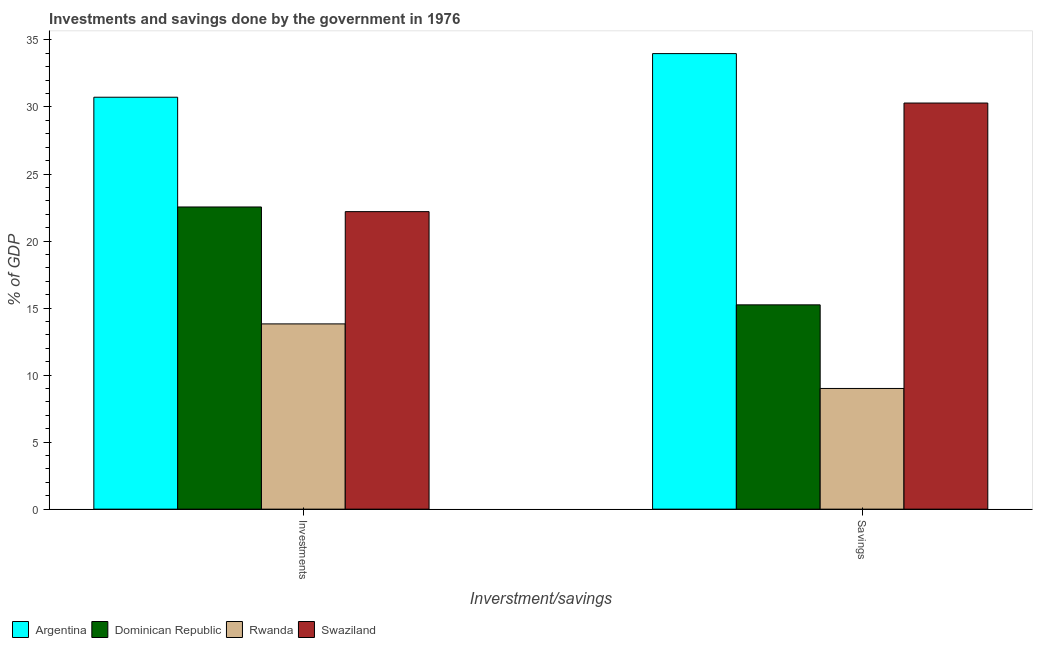How many different coloured bars are there?
Make the answer very short. 4. How many groups of bars are there?
Provide a succinct answer. 2. Are the number of bars on each tick of the X-axis equal?
Provide a succinct answer. Yes. What is the label of the 1st group of bars from the left?
Your response must be concise. Investments. What is the investments of government in Swaziland?
Offer a terse response. 22.19. Across all countries, what is the maximum investments of government?
Ensure brevity in your answer.  30.73. Across all countries, what is the minimum savings of government?
Provide a short and direct response. 9. In which country was the savings of government minimum?
Your answer should be compact. Rwanda. What is the total savings of government in the graph?
Give a very brief answer. 88.52. What is the difference between the investments of government in Argentina and that in Rwanda?
Provide a succinct answer. 16.91. What is the difference between the investments of government in Rwanda and the savings of government in Argentina?
Keep it short and to the point. -20.16. What is the average investments of government per country?
Keep it short and to the point. 22.32. What is the difference between the investments of government and savings of government in Rwanda?
Provide a short and direct response. 4.82. In how many countries, is the savings of government greater than 22 %?
Provide a succinct answer. 2. What is the ratio of the investments of government in Argentina to that in Swaziland?
Give a very brief answer. 1.38. Is the investments of government in Swaziland less than that in Dominican Republic?
Ensure brevity in your answer.  Yes. What does the 4th bar from the left in Investments represents?
Offer a terse response. Swaziland. What does the 3rd bar from the right in Investments represents?
Make the answer very short. Dominican Republic. Are all the bars in the graph horizontal?
Offer a very short reply. No. How many countries are there in the graph?
Provide a succinct answer. 4. Does the graph contain grids?
Provide a succinct answer. No. Where does the legend appear in the graph?
Your response must be concise. Bottom left. How many legend labels are there?
Provide a succinct answer. 4. How are the legend labels stacked?
Your answer should be compact. Horizontal. What is the title of the graph?
Your response must be concise. Investments and savings done by the government in 1976. What is the label or title of the X-axis?
Offer a very short reply. Inverstment/savings. What is the label or title of the Y-axis?
Provide a short and direct response. % of GDP. What is the % of GDP of Argentina in Investments?
Keep it short and to the point. 30.73. What is the % of GDP of Dominican Republic in Investments?
Your response must be concise. 22.54. What is the % of GDP of Rwanda in Investments?
Provide a succinct answer. 13.82. What is the % of GDP of Swaziland in Investments?
Give a very brief answer. 22.19. What is the % of GDP in Argentina in Savings?
Provide a short and direct response. 33.98. What is the % of GDP of Dominican Republic in Savings?
Make the answer very short. 15.24. What is the % of GDP of Rwanda in Savings?
Keep it short and to the point. 9. What is the % of GDP of Swaziland in Savings?
Your response must be concise. 30.3. Across all Inverstment/savings, what is the maximum % of GDP of Argentina?
Your answer should be compact. 33.98. Across all Inverstment/savings, what is the maximum % of GDP in Dominican Republic?
Provide a succinct answer. 22.54. Across all Inverstment/savings, what is the maximum % of GDP in Rwanda?
Offer a very short reply. 13.82. Across all Inverstment/savings, what is the maximum % of GDP of Swaziland?
Your answer should be compact. 30.3. Across all Inverstment/savings, what is the minimum % of GDP in Argentina?
Your response must be concise. 30.73. Across all Inverstment/savings, what is the minimum % of GDP in Dominican Republic?
Provide a succinct answer. 15.24. Across all Inverstment/savings, what is the minimum % of GDP of Rwanda?
Keep it short and to the point. 9. Across all Inverstment/savings, what is the minimum % of GDP in Swaziland?
Your answer should be very brief. 22.19. What is the total % of GDP of Argentina in the graph?
Ensure brevity in your answer.  64.71. What is the total % of GDP of Dominican Republic in the graph?
Keep it short and to the point. 37.78. What is the total % of GDP of Rwanda in the graph?
Keep it short and to the point. 22.82. What is the total % of GDP in Swaziland in the graph?
Provide a short and direct response. 52.49. What is the difference between the % of GDP in Argentina in Investments and that in Savings?
Ensure brevity in your answer.  -3.25. What is the difference between the % of GDP of Dominican Republic in Investments and that in Savings?
Offer a very short reply. 7.3. What is the difference between the % of GDP in Rwanda in Investments and that in Savings?
Make the answer very short. 4.82. What is the difference between the % of GDP of Swaziland in Investments and that in Savings?
Your response must be concise. -8.1. What is the difference between the % of GDP of Argentina in Investments and the % of GDP of Dominican Republic in Savings?
Keep it short and to the point. 15.49. What is the difference between the % of GDP of Argentina in Investments and the % of GDP of Rwanda in Savings?
Make the answer very short. 21.73. What is the difference between the % of GDP of Argentina in Investments and the % of GDP of Swaziland in Savings?
Keep it short and to the point. 0.43. What is the difference between the % of GDP of Dominican Republic in Investments and the % of GDP of Rwanda in Savings?
Keep it short and to the point. 13.54. What is the difference between the % of GDP of Dominican Republic in Investments and the % of GDP of Swaziland in Savings?
Your answer should be compact. -7.75. What is the difference between the % of GDP in Rwanda in Investments and the % of GDP in Swaziland in Savings?
Provide a succinct answer. -16.48. What is the average % of GDP in Argentina per Inverstment/savings?
Give a very brief answer. 32.36. What is the average % of GDP in Dominican Republic per Inverstment/savings?
Keep it short and to the point. 18.89. What is the average % of GDP of Rwanda per Inverstment/savings?
Give a very brief answer. 11.41. What is the average % of GDP in Swaziland per Inverstment/savings?
Ensure brevity in your answer.  26.24. What is the difference between the % of GDP in Argentina and % of GDP in Dominican Republic in Investments?
Give a very brief answer. 8.19. What is the difference between the % of GDP in Argentina and % of GDP in Rwanda in Investments?
Provide a short and direct response. 16.91. What is the difference between the % of GDP of Argentina and % of GDP of Swaziland in Investments?
Make the answer very short. 8.54. What is the difference between the % of GDP in Dominican Republic and % of GDP in Rwanda in Investments?
Keep it short and to the point. 8.72. What is the difference between the % of GDP of Dominican Republic and % of GDP of Swaziland in Investments?
Offer a terse response. 0.35. What is the difference between the % of GDP of Rwanda and % of GDP of Swaziland in Investments?
Offer a very short reply. -8.37. What is the difference between the % of GDP of Argentina and % of GDP of Dominican Republic in Savings?
Your answer should be very brief. 18.74. What is the difference between the % of GDP in Argentina and % of GDP in Rwanda in Savings?
Your response must be concise. 24.98. What is the difference between the % of GDP in Argentina and % of GDP in Swaziland in Savings?
Offer a very short reply. 3.69. What is the difference between the % of GDP in Dominican Republic and % of GDP in Rwanda in Savings?
Provide a succinct answer. 6.24. What is the difference between the % of GDP in Dominican Republic and % of GDP in Swaziland in Savings?
Your answer should be very brief. -15.06. What is the difference between the % of GDP of Rwanda and % of GDP of Swaziland in Savings?
Offer a very short reply. -21.29. What is the ratio of the % of GDP of Argentina in Investments to that in Savings?
Offer a terse response. 0.9. What is the ratio of the % of GDP in Dominican Republic in Investments to that in Savings?
Give a very brief answer. 1.48. What is the ratio of the % of GDP of Rwanda in Investments to that in Savings?
Provide a succinct answer. 1.53. What is the ratio of the % of GDP of Swaziland in Investments to that in Savings?
Offer a terse response. 0.73. What is the difference between the highest and the second highest % of GDP in Argentina?
Keep it short and to the point. 3.25. What is the difference between the highest and the second highest % of GDP of Dominican Republic?
Keep it short and to the point. 7.3. What is the difference between the highest and the second highest % of GDP in Rwanda?
Provide a succinct answer. 4.82. What is the difference between the highest and the second highest % of GDP in Swaziland?
Make the answer very short. 8.1. What is the difference between the highest and the lowest % of GDP in Argentina?
Offer a terse response. 3.25. What is the difference between the highest and the lowest % of GDP in Dominican Republic?
Provide a short and direct response. 7.3. What is the difference between the highest and the lowest % of GDP of Rwanda?
Your answer should be very brief. 4.82. What is the difference between the highest and the lowest % of GDP in Swaziland?
Give a very brief answer. 8.1. 